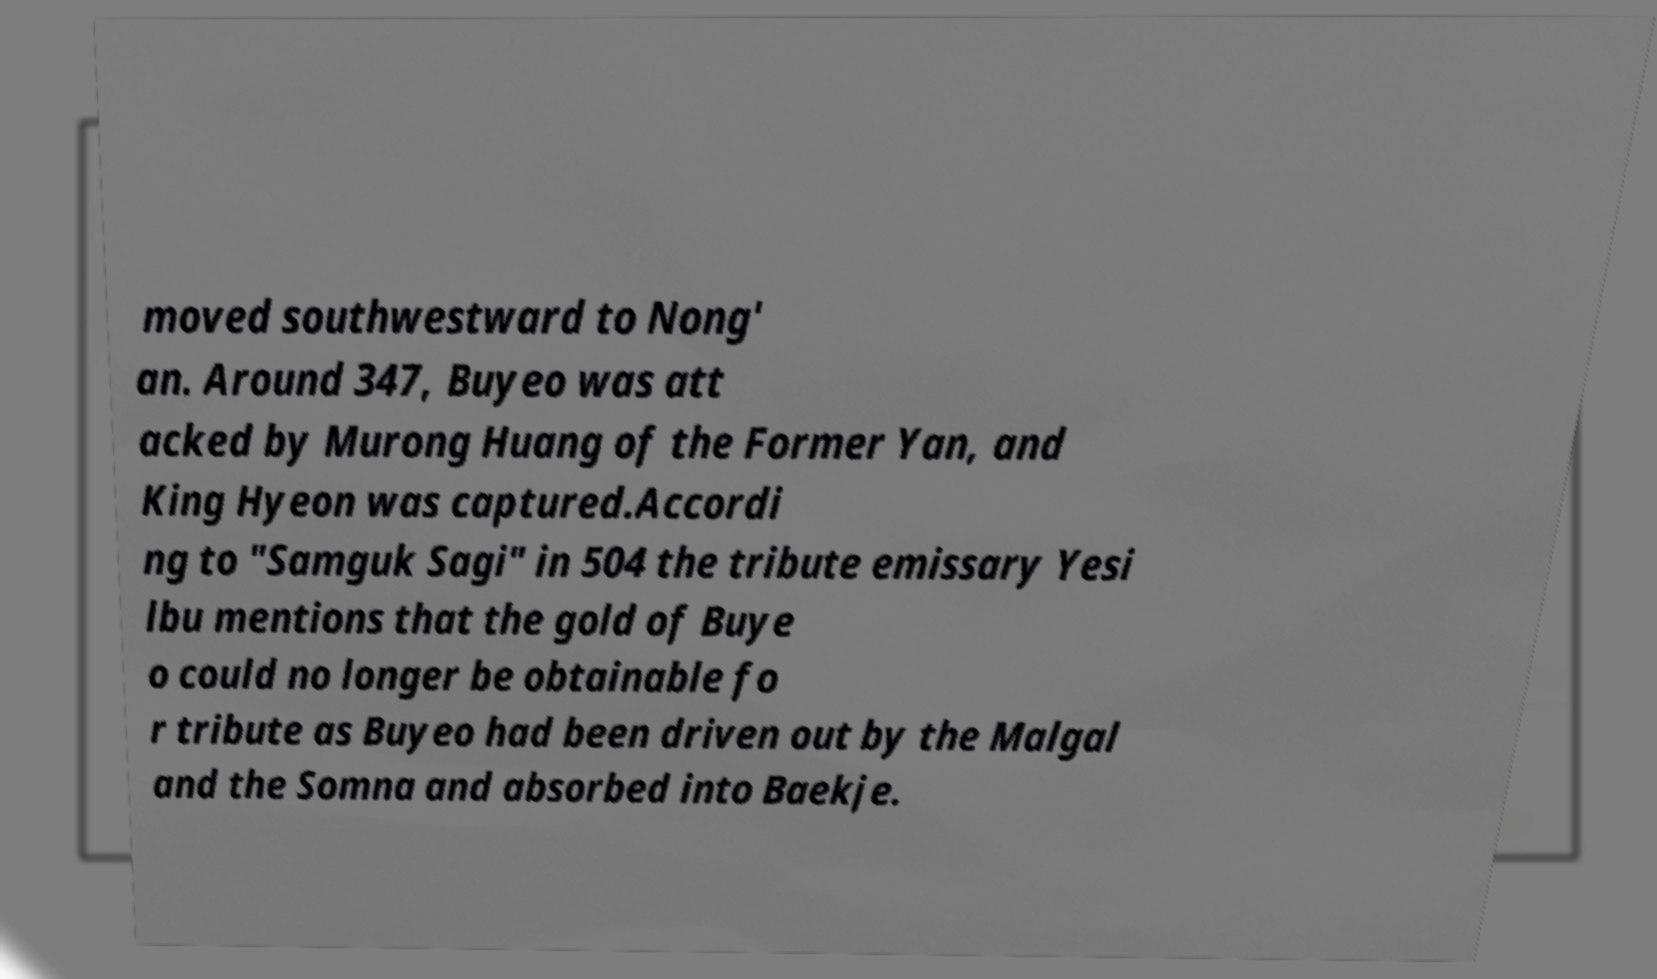Please read and relay the text visible in this image. What does it say? moved southwestward to Nong' an. Around 347, Buyeo was att acked by Murong Huang of the Former Yan, and King Hyeon was captured.Accordi ng to "Samguk Sagi" in 504 the tribute emissary Yesi lbu mentions that the gold of Buye o could no longer be obtainable fo r tribute as Buyeo had been driven out by the Malgal and the Somna and absorbed into Baekje. 